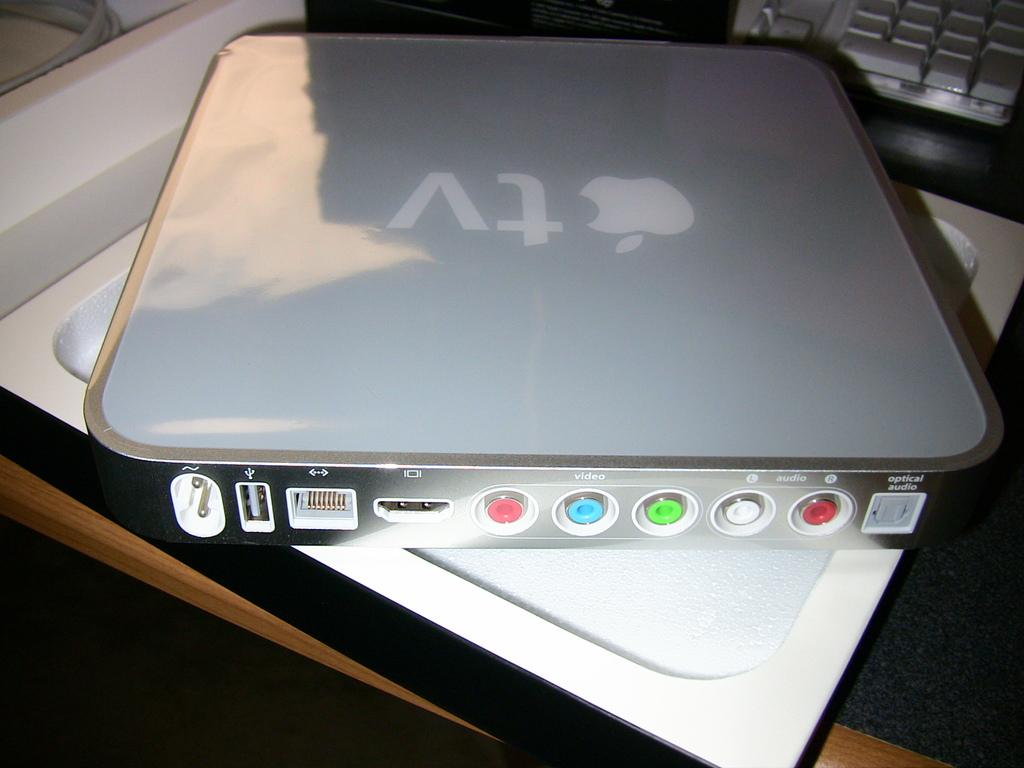Provide a one-sentence caption for the provided image. An older version of an AppleTV in the box. 